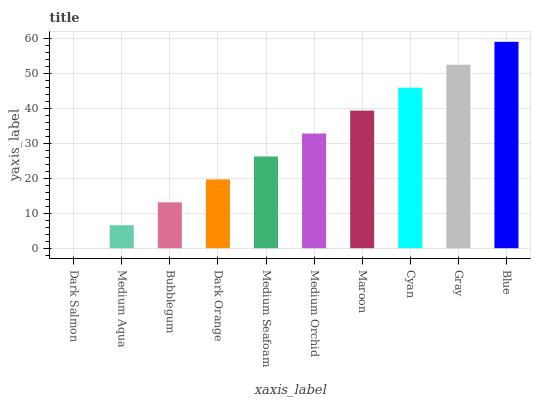Is Dark Salmon the minimum?
Answer yes or no. Yes. Is Blue the maximum?
Answer yes or no. Yes. Is Medium Aqua the minimum?
Answer yes or no. No. Is Medium Aqua the maximum?
Answer yes or no. No. Is Medium Aqua greater than Dark Salmon?
Answer yes or no. Yes. Is Dark Salmon less than Medium Aqua?
Answer yes or no. Yes. Is Dark Salmon greater than Medium Aqua?
Answer yes or no. No. Is Medium Aqua less than Dark Salmon?
Answer yes or no. No. Is Medium Orchid the high median?
Answer yes or no. Yes. Is Medium Seafoam the low median?
Answer yes or no. Yes. Is Gray the high median?
Answer yes or no. No. Is Maroon the low median?
Answer yes or no. No. 